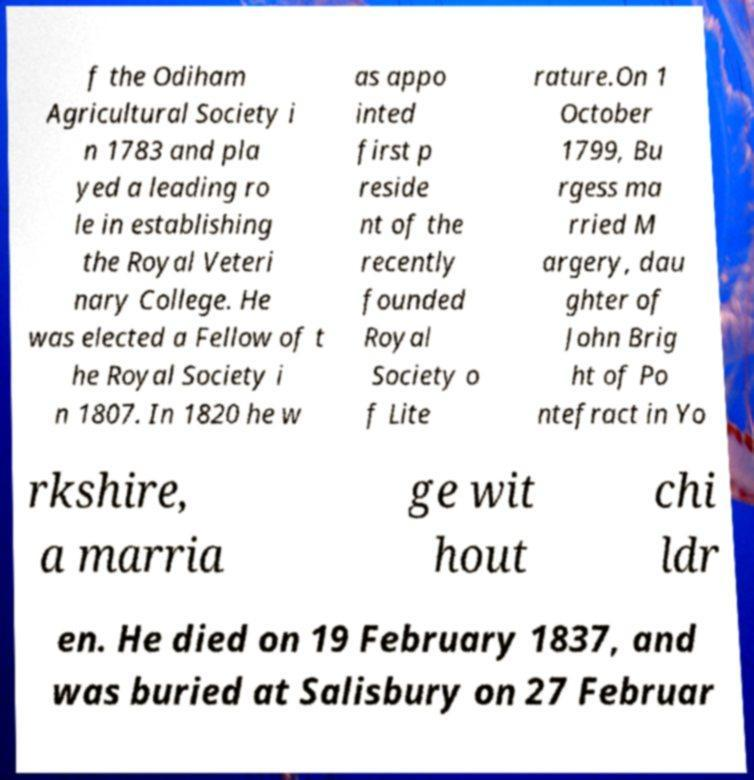There's text embedded in this image that I need extracted. Can you transcribe it verbatim? f the Odiham Agricultural Society i n 1783 and pla yed a leading ro le in establishing the Royal Veteri nary College. He was elected a Fellow of t he Royal Society i n 1807. In 1820 he w as appo inted first p reside nt of the recently founded Royal Society o f Lite rature.On 1 October 1799, Bu rgess ma rried M argery, dau ghter of John Brig ht of Po ntefract in Yo rkshire, a marria ge wit hout chi ldr en. He died on 19 February 1837, and was buried at Salisbury on 27 Februar 